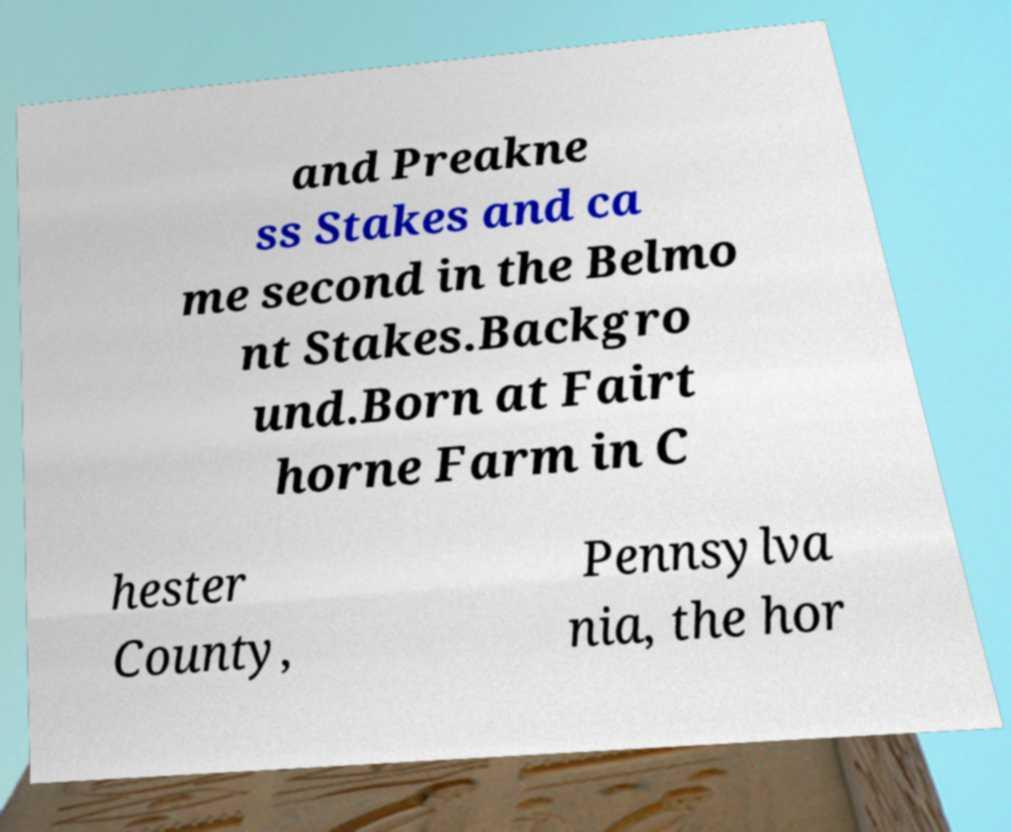Please identify and transcribe the text found in this image. and Preakne ss Stakes and ca me second in the Belmo nt Stakes.Backgro und.Born at Fairt horne Farm in C hester County, Pennsylva nia, the hor 